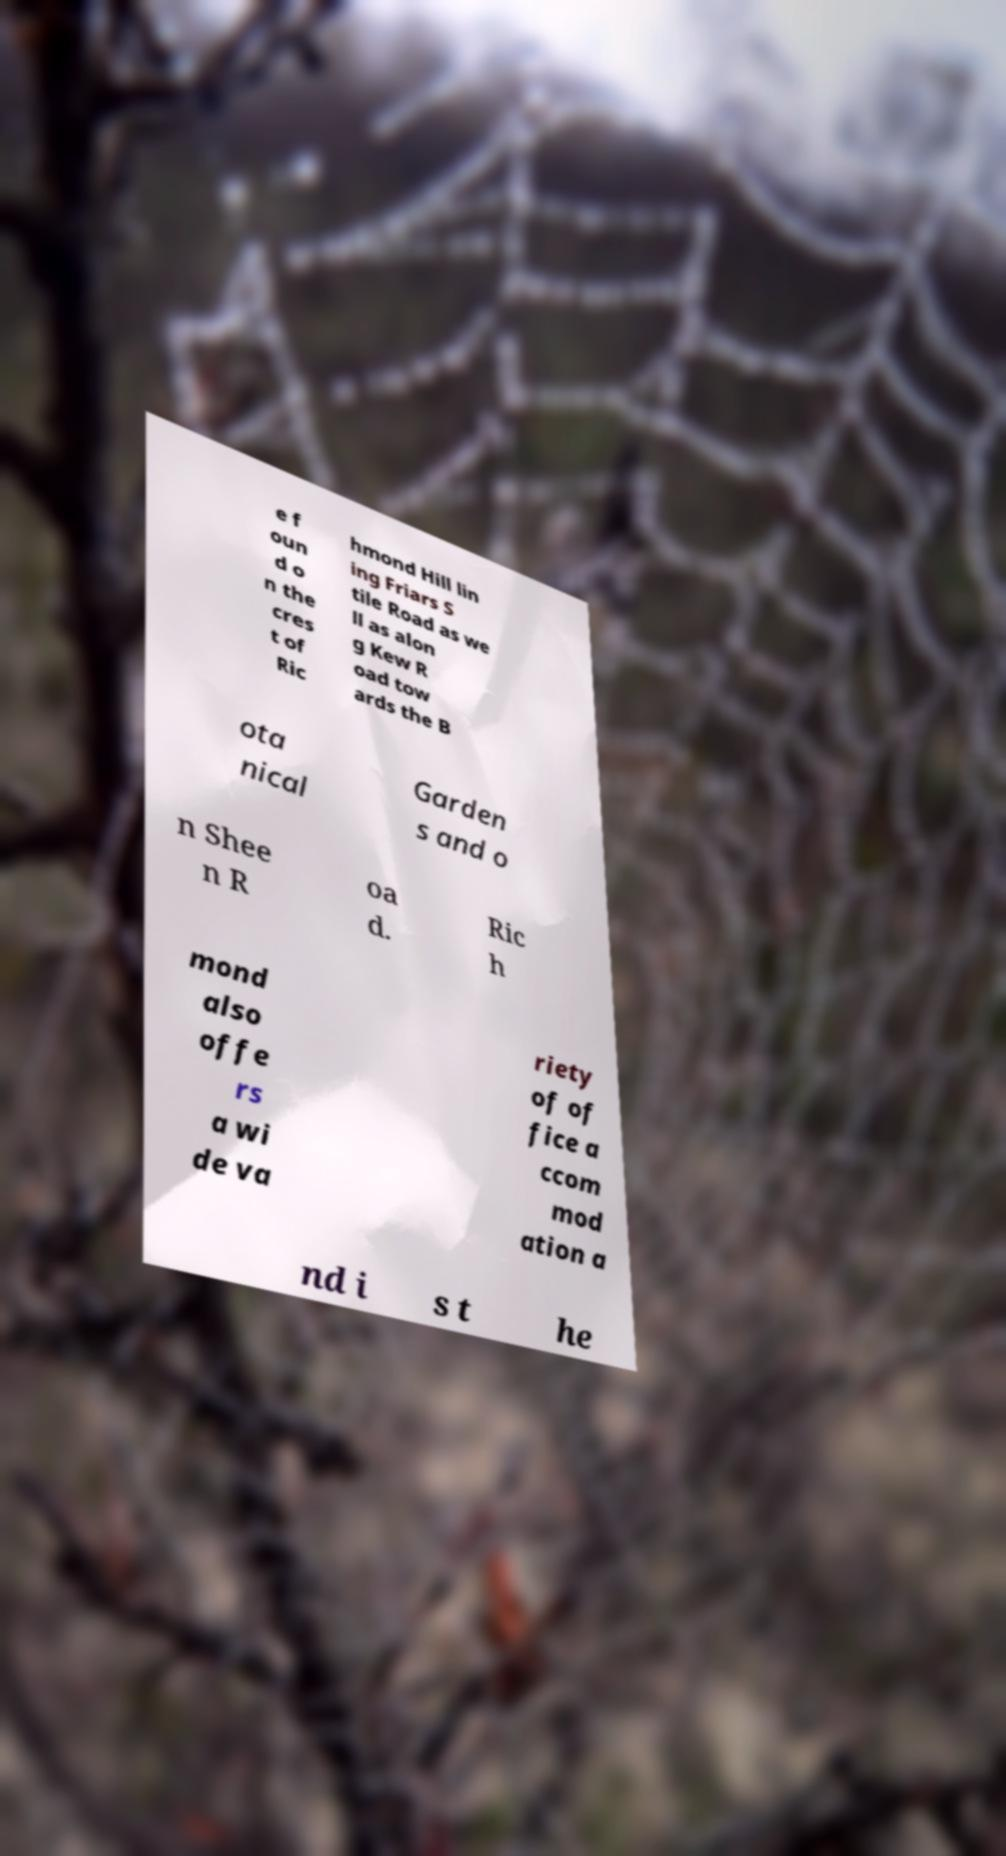For documentation purposes, I need the text within this image transcribed. Could you provide that? e f oun d o n the cres t of Ric hmond Hill lin ing Friars S tile Road as we ll as alon g Kew R oad tow ards the B ota nical Garden s and o n Shee n R oa d. Ric h mond also offe rs a wi de va riety of of fice a ccom mod ation a nd i s t he 